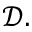Convert formula to latex. <formula><loc_0><loc_0><loc_500><loc_500>\mathcal { D } .</formula> 